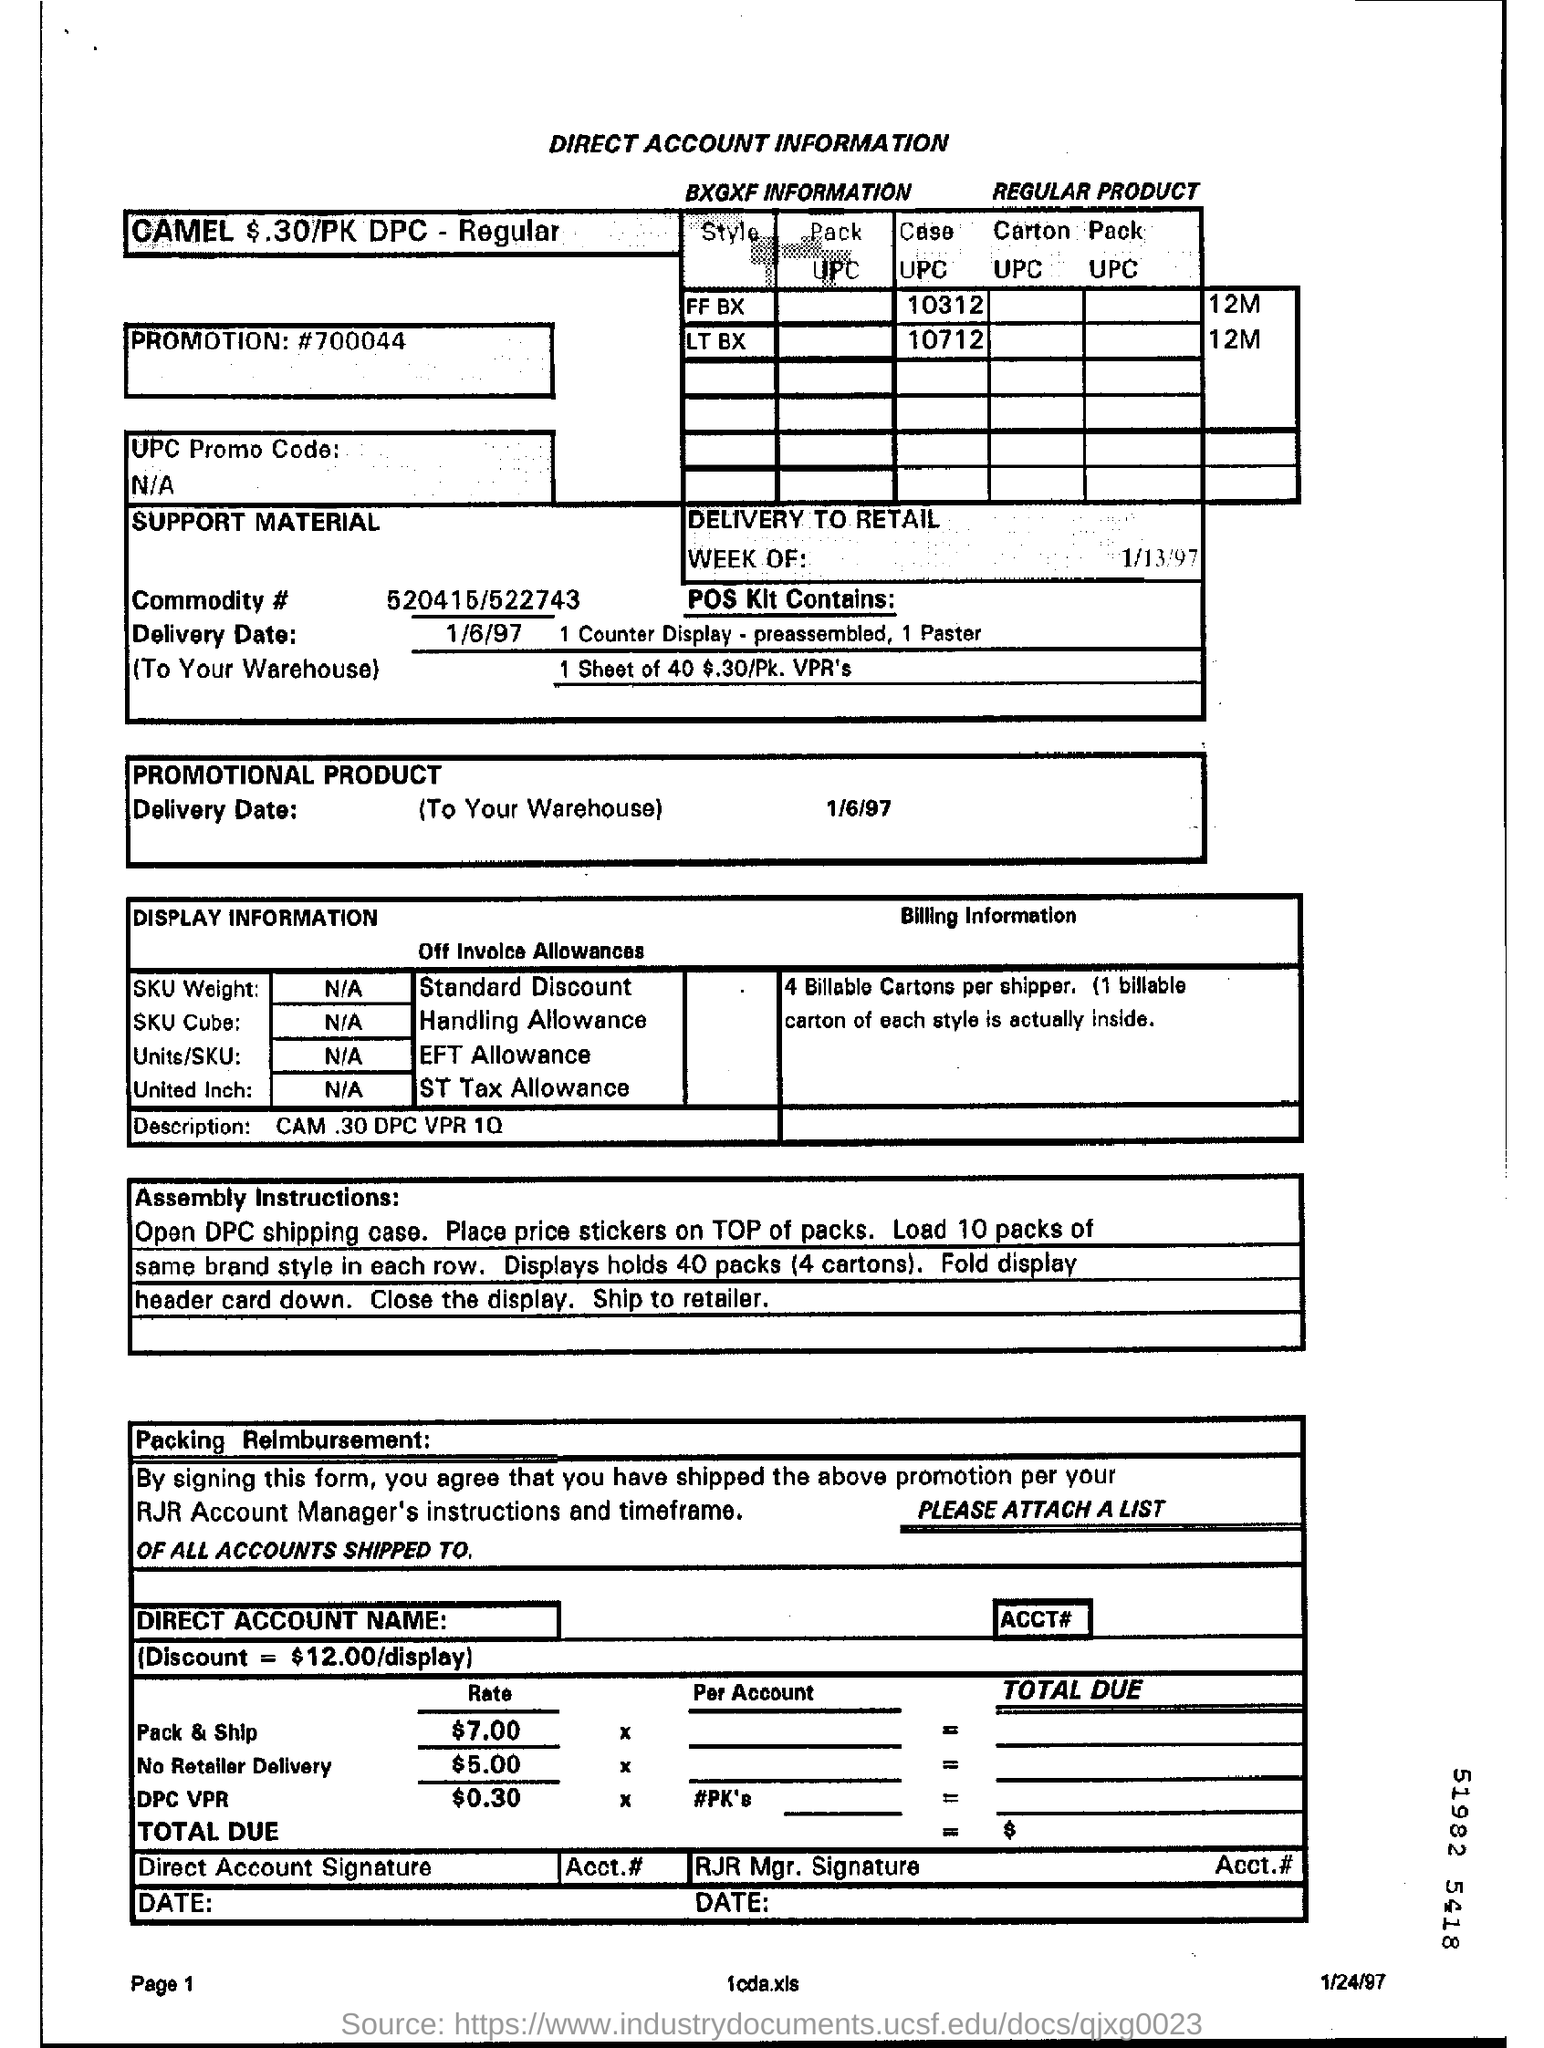Give some essential details in this illustration. The delivery date mentioned is January 6, 1997. I'm sorry, but your message appears to be incomplete and contains unfamiliar symbols. Could you please clarify or provide more information? The rate mentioned is $5.00 for no retailer delivery. The rate for pack and ship is $7.00. 